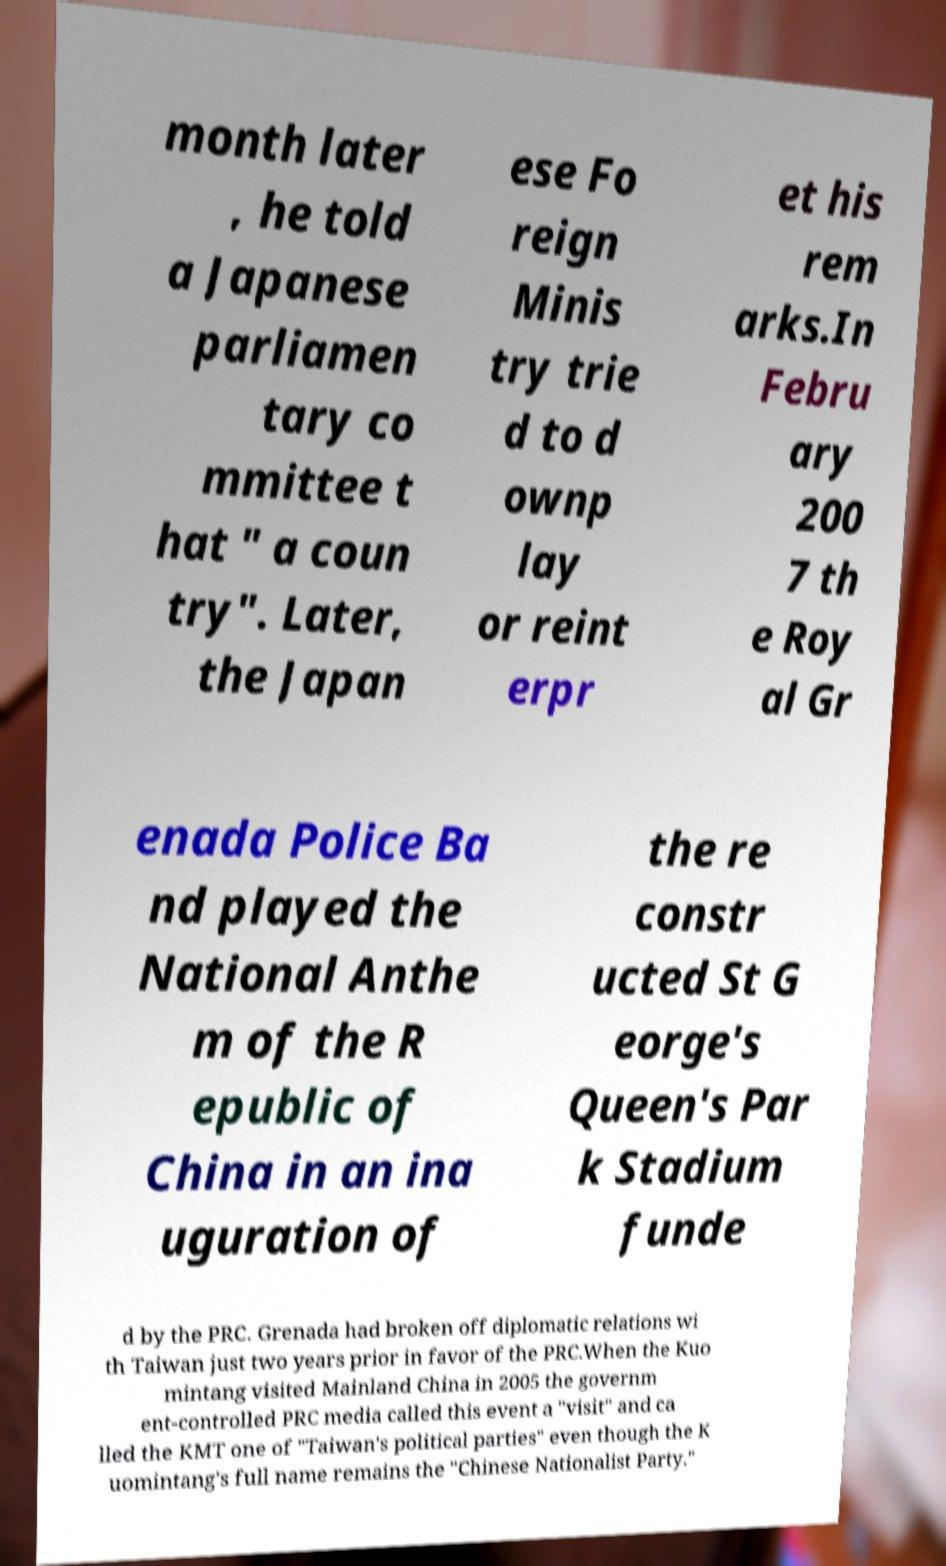I need the written content from this picture converted into text. Can you do that? month later , he told a Japanese parliamen tary co mmittee t hat " a coun try". Later, the Japan ese Fo reign Minis try trie d to d ownp lay or reint erpr et his rem arks.In Febru ary 200 7 th e Roy al Gr enada Police Ba nd played the National Anthe m of the R epublic of China in an ina uguration of the re constr ucted St G eorge's Queen's Par k Stadium funde d by the PRC. Grenada had broken off diplomatic relations wi th Taiwan just two years prior in favor of the PRC.When the Kuo mintang visited Mainland China in 2005 the governm ent-controlled PRC media called this event a "visit" and ca lled the KMT one of "Taiwan's political parties" even though the K uomintang's full name remains the "Chinese Nationalist Party." 